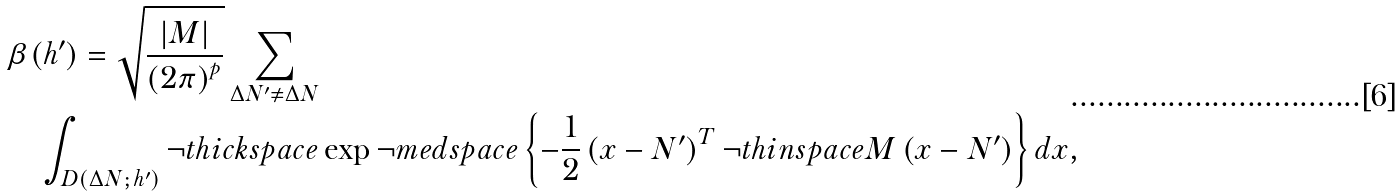Convert formula to latex. <formula><loc_0><loc_0><loc_500><loc_500>& \beta ( h ^ { \prime } ) = \sqrt { \frac { | M | } { \left ( 2 \pi \right ) ^ { p } } } \sum _ { \Delta N ^ { \prime } \neq \Delta N } \\ & \quad \int _ { D ( \Delta N ; \, h ^ { \prime } ) } \neg t h i c k s p a c e \exp \neg m e d s p a c e \left \{ - \frac { 1 } { 2 } \left ( x - N ^ { \prime } \right ) ^ { T } \neg t h i n s p a c e M \left ( x - N ^ { \prime } \right ) \right \} d x ,</formula> 